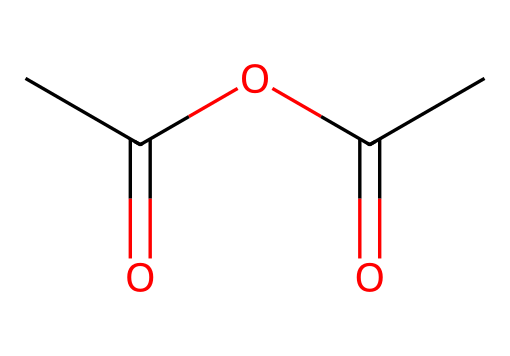What is the molecular formula of this chemical? In the given SMILES representation, we can identify the number of carbon (C), hydrogen (H), and oxygen (O) atoms. Counting them gives C4 (4 carbon atoms), H6 (6 hydrogen atoms), and O3 (3 oxygen atoms). Therefore, the molecular formula is derived from these counts.
Answer: C4H6O3 How many carbon atoms are present in acetic anhydride? By examining the SMILES, we can see that there are a total of 4 carbon atoms present. This is obtained by counting the 'C's in the structure.
Answer: 4 What type of functional groups are present in this chemical? The structure contains two acetyl groups linked through an anhydride bond. This indicates that the main functional group present is the acid anhydride, characterized by the joining of two acyl groups.
Answer: acid anhydride How many double bonds are there in acetic anhydride? Within this chemical, there are two double bonds between carbon and oxygen (C=O) in the acid anhydride structure. This can be identified by looking at the connections in the SMILES.
Answer: 2 What is the significance of the anhydride functional group in aspirin synthesis? The anhydride functional group allows the acetic anhydride to react with salicylic acid to form aspirin through an esterification reaction, where one acetate group is transferred. This is important in determining its reactivity in synthesizing aspirin.
Answer: reactivity What is the total number of oxygen atoms in this chemical? The SMILES representation indicates that there are 3 oxygen atoms present (O). By simply counting the occurrences of 'O' in the structure, we find that the total is 3.
Answer: 3 Does acetic anhydride have any notable physical properties? Acetic anhydride is known to be a colorless liquid with an acrid smell that can be irritating; these properties can be inferred based on general knowledge of anhydrides.
Answer: colorless liquid 